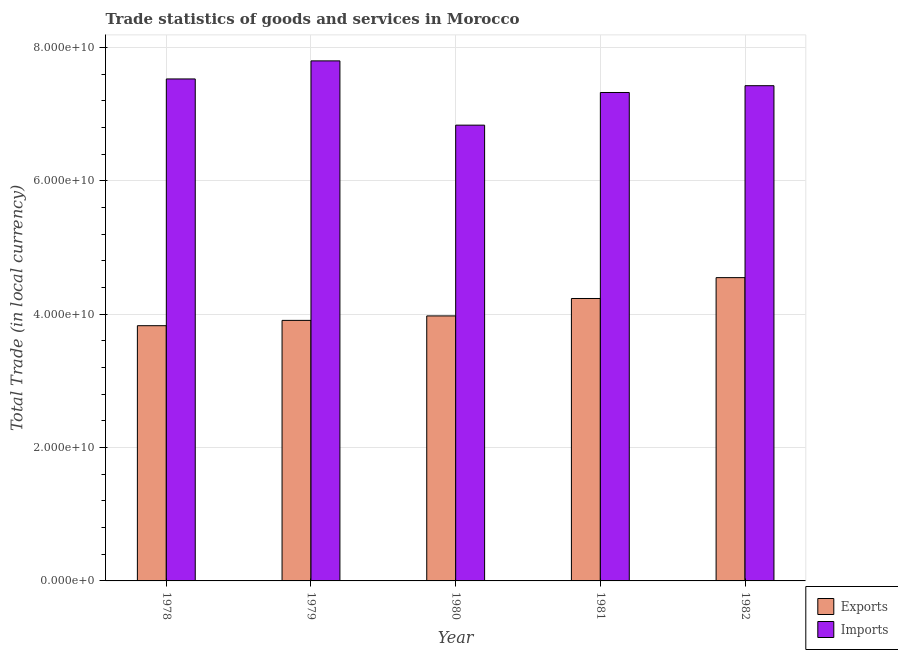Are the number of bars per tick equal to the number of legend labels?
Provide a succinct answer. Yes. Are the number of bars on each tick of the X-axis equal?
Provide a short and direct response. Yes. In how many cases, is the number of bars for a given year not equal to the number of legend labels?
Provide a succinct answer. 0. What is the export of goods and services in 1979?
Ensure brevity in your answer.  3.91e+1. Across all years, what is the maximum export of goods and services?
Your response must be concise. 4.55e+1. Across all years, what is the minimum export of goods and services?
Offer a very short reply. 3.83e+1. In which year was the export of goods and services minimum?
Make the answer very short. 1978. What is the total imports of goods and services in the graph?
Make the answer very short. 3.69e+11. What is the difference between the export of goods and services in 1978 and that in 1979?
Give a very brief answer. -7.99e+08. What is the difference between the imports of goods and services in 1978 and the export of goods and services in 1979?
Offer a very short reply. -2.71e+09. What is the average export of goods and services per year?
Keep it short and to the point. 4.10e+1. In how many years, is the imports of goods and services greater than 48000000000 LCU?
Your answer should be compact. 5. What is the ratio of the imports of goods and services in 1979 to that in 1981?
Keep it short and to the point. 1.06. Is the export of goods and services in 1978 less than that in 1980?
Offer a terse response. Yes. What is the difference between the highest and the second highest imports of goods and services?
Make the answer very short. 2.71e+09. What is the difference between the highest and the lowest imports of goods and services?
Keep it short and to the point. 9.64e+09. In how many years, is the imports of goods and services greater than the average imports of goods and services taken over all years?
Ensure brevity in your answer.  3. Is the sum of the export of goods and services in 1978 and 1982 greater than the maximum imports of goods and services across all years?
Ensure brevity in your answer.  Yes. What does the 1st bar from the left in 1982 represents?
Keep it short and to the point. Exports. What does the 1st bar from the right in 1979 represents?
Give a very brief answer. Imports. What is the difference between two consecutive major ticks on the Y-axis?
Give a very brief answer. 2.00e+1. Are the values on the major ticks of Y-axis written in scientific E-notation?
Keep it short and to the point. Yes. Does the graph contain grids?
Offer a very short reply. Yes. Where does the legend appear in the graph?
Keep it short and to the point. Bottom right. How many legend labels are there?
Provide a succinct answer. 2. What is the title of the graph?
Ensure brevity in your answer.  Trade statistics of goods and services in Morocco. What is the label or title of the X-axis?
Your response must be concise. Year. What is the label or title of the Y-axis?
Offer a terse response. Total Trade (in local currency). What is the Total Trade (in local currency) of Exports in 1978?
Give a very brief answer. 3.83e+1. What is the Total Trade (in local currency) in Imports in 1978?
Your response must be concise. 7.53e+1. What is the Total Trade (in local currency) in Exports in 1979?
Keep it short and to the point. 3.91e+1. What is the Total Trade (in local currency) in Imports in 1979?
Offer a very short reply. 7.80e+1. What is the Total Trade (in local currency) of Exports in 1980?
Give a very brief answer. 3.97e+1. What is the Total Trade (in local currency) of Imports in 1980?
Provide a succinct answer. 6.84e+1. What is the Total Trade (in local currency) in Exports in 1981?
Make the answer very short. 4.24e+1. What is the Total Trade (in local currency) in Imports in 1981?
Your answer should be compact. 7.33e+1. What is the Total Trade (in local currency) of Exports in 1982?
Your response must be concise. 4.55e+1. What is the Total Trade (in local currency) in Imports in 1982?
Your response must be concise. 7.43e+1. Across all years, what is the maximum Total Trade (in local currency) of Exports?
Ensure brevity in your answer.  4.55e+1. Across all years, what is the maximum Total Trade (in local currency) of Imports?
Offer a very short reply. 7.80e+1. Across all years, what is the minimum Total Trade (in local currency) of Exports?
Provide a succinct answer. 3.83e+1. Across all years, what is the minimum Total Trade (in local currency) in Imports?
Your answer should be very brief. 6.84e+1. What is the total Total Trade (in local currency) of Exports in the graph?
Your answer should be very brief. 2.05e+11. What is the total Total Trade (in local currency) in Imports in the graph?
Provide a short and direct response. 3.69e+11. What is the difference between the Total Trade (in local currency) of Exports in 1978 and that in 1979?
Provide a succinct answer. -7.99e+08. What is the difference between the Total Trade (in local currency) of Imports in 1978 and that in 1979?
Give a very brief answer. -2.71e+09. What is the difference between the Total Trade (in local currency) in Exports in 1978 and that in 1980?
Provide a succinct answer. -1.47e+09. What is the difference between the Total Trade (in local currency) in Imports in 1978 and that in 1980?
Your answer should be compact. 6.93e+09. What is the difference between the Total Trade (in local currency) of Exports in 1978 and that in 1981?
Keep it short and to the point. -4.08e+09. What is the difference between the Total Trade (in local currency) in Imports in 1978 and that in 1981?
Your response must be concise. 2.03e+09. What is the difference between the Total Trade (in local currency) in Exports in 1978 and that in 1982?
Your answer should be compact. -7.21e+09. What is the difference between the Total Trade (in local currency) of Imports in 1978 and that in 1982?
Offer a very short reply. 1.01e+09. What is the difference between the Total Trade (in local currency) of Exports in 1979 and that in 1980?
Offer a terse response. -6.69e+08. What is the difference between the Total Trade (in local currency) in Imports in 1979 and that in 1980?
Provide a succinct answer. 9.64e+09. What is the difference between the Total Trade (in local currency) in Exports in 1979 and that in 1981?
Your response must be concise. -3.28e+09. What is the difference between the Total Trade (in local currency) in Imports in 1979 and that in 1981?
Provide a succinct answer. 4.74e+09. What is the difference between the Total Trade (in local currency) in Exports in 1979 and that in 1982?
Make the answer very short. -6.41e+09. What is the difference between the Total Trade (in local currency) in Imports in 1979 and that in 1982?
Give a very brief answer. 3.72e+09. What is the difference between the Total Trade (in local currency) of Exports in 1980 and that in 1981?
Provide a short and direct response. -2.61e+09. What is the difference between the Total Trade (in local currency) of Imports in 1980 and that in 1981?
Make the answer very short. -4.90e+09. What is the difference between the Total Trade (in local currency) of Exports in 1980 and that in 1982?
Keep it short and to the point. -5.74e+09. What is the difference between the Total Trade (in local currency) of Imports in 1980 and that in 1982?
Make the answer very short. -5.92e+09. What is the difference between the Total Trade (in local currency) in Exports in 1981 and that in 1982?
Offer a terse response. -3.13e+09. What is the difference between the Total Trade (in local currency) of Imports in 1981 and that in 1982?
Your answer should be compact. -1.02e+09. What is the difference between the Total Trade (in local currency) of Exports in 1978 and the Total Trade (in local currency) of Imports in 1979?
Your answer should be compact. -3.97e+1. What is the difference between the Total Trade (in local currency) in Exports in 1978 and the Total Trade (in local currency) in Imports in 1980?
Your answer should be very brief. -3.01e+1. What is the difference between the Total Trade (in local currency) of Exports in 1978 and the Total Trade (in local currency) of Imports in 1981?
Offer a terse response. -3.50e+1. What is the difference between the Total Trade (in local currency) in Exports in 1978 and the Total Trade (in local currency) in Imports in 1982?
Give a very brief answer. -3.60e+1. What is the difference between the Total Trade (in local currency) in Exports in 1979 and the Total Trade (in local currency) in Imports in 1980?
Provide a succinct answer. -2.93e+1. What is the difference between the Total Trade (in local currency) in Exports in 1979 and the Total Trade (in local currency) in Imports in 1981?
Your answer should be compact. -3.42e+1. What is the difference between the Total Trade (in local currency) of Exports in 1979 and the Total Trade (in local currency) of Imports in 1982?
Make the answer very short. -3.52e+1. What is the difference between the Total Trade (in local currency) in Exports in 1980 and the Total Trade (in local currency) in Imports in 1981?
Provide a succinct answer. -3.35e+1. What is the difference between the Total Trade (in local currency) in Exports in 1980 and the Total Trade (in local currency) in Imports in 1982?
Your response must be concise. -3.45e+1. What is the difference between the Total Trade (in local currency) in Exports in 1981 and the Total Trade (in local currency) in Imports in 1982?
Your answer should be very brief. -3.19e+1. What is the average Total Trade (in local currency) in Exports per year?
Make the answer very short. 4.10e+1. What is the average Total Trade (in local currency) in Imports per year?
Offer a terse response. 7.38e+1. In the year 1978, what is the difference between the Total Trade (in local currency) in Exports and Total Trade (in local currency) in Imports?
Make the answer very short. -3.70e+1. In the year 1979, what is the difference between the Total Trade (in local currency) in Exports and Total Trade (in local currency) in Imports?
Your response must be concise. -3.89e+1. In the year 1980, what is the difference between the Total Trade (in local currency) in Exports and Total Trade (in local currency) in Imports?
Your response must be concise. -2.86e+1. In the year 1981, what is the difference between the Total Trade (in local currency) of Exports and Total Trade (in local currency) of Imports?
Your response must be concise. -3.09e+1. In the year 1982, what is the difference between the Total Trade (in local currency) in Exports and Total Trade (in local currency) in Imports?
Offer a terse response. -2.88e+1. What is the ratio of the Total Trade (in local currency) in Exports in 1978 to that in 1979?
Your response must be concise. 0.98. What is the ratio of the Total Trade (in local currency) in Imports in 1978 to that in 1979?
Ensure brevity in your answer.  0.97. What is the ratio of the Total Trade (in local currency) in Exports in 1978 to that in 1980?
Offer a terse response. 0.96. What is the ratio of the Total Trade (in local currency) of Imports in 1978 to that in 1980?
Provide a short and direct response. 1.1. What is the ratio of the Total Trade (in local currency) in Exports in 1978 to that in 1981?
Offer a very short reply. 0.9. What is the ratio of the Total Trade (in local currency) in Imports in 1978 to that in 1981?
Keep it short and to the point. 1.03. What is the ratio of the Total Trade (in local currency) in Exports in 1978 to that in 1982?
Your answer should be very brief. 0.84. What is the ratio of the Total Trade (in local currency) in Imports in 1978 to that in 1982?
Offer a very short reply. 1.01. What is the ratio of the Total Trade (in local currency) of Exports in 1979 to that in 1980?
Your answer should be compact. 0.98. What is the ratio of the Total Trade (in local currency) of Imports in 1979 to that in 1980?
Ensure brevity in your answer.  1.14. What is the ratio of the Total Trade (in local currency) of Exports in 1979 to that in 1981?
Keep it short and to the point. 0.92. What is the ratio of the Total Trade (in local currency) of Imports in 1979 to that in 1981?
Ensure brevity in your answer.  1.06. What is the ratio of the Total Trade (in local currency) of Exports in 1979 to that in 1982?
Keep it short and to the point. 0.86. What is the ratio of the Total Trade (in local currency) of Imports in 1979 to that in 1982?
Keep it short and to the point. 1.05. What is the ratio of the Total Trade (in local currency) of Exports in 1980 to that in 1981?
Keep it short and to the point. 0.94. What is the ratio of the Total Trade (in local currency) of Imports in 1980 to that in 1981?
Provide a succinct answer. 0.93. What is the ratio of the Total Trade (in local currency) of Exports in 1980 to that in 1982?
Your answer should be compact. 0.87. What is the ratio of the Total Trade (in local currency) in Imports in 1980 to that in 1982?
Your answer should be very brief. 0.92. What is the ratio of the Total Trade (in local currency) of Exports in 1981 to that in 1982?
Your response must be concise. 0.93. What is the ratio of the Total Trade (in local currency) in Imports in 1981 to that in 1982?
Offer a terse response. 0.99. What is the difference between the highest and the second highest Total Trade (in local currency) of Exports?
Make the answer very short. 3.13e+09. What is the difference between the highest and the second highest Total Trade (in local currency) of Imports?
Ensure brevity in your answer.  2.71e+09. What is the difference between the highest and the lowest Total Trade (in local currency) in Exports?
Provide a short and direct response. 7.21e+09. What is the difference between the highest and the lowest Total Trade (in local currency) of Imports?
Offer a very short reply. 9.64e+09. 